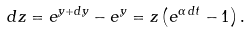Convert formula to latex. <formula><loc_0><loc_0><loc_500><loc_500>d z = e ^ { y + d y } - e ^ { y } = z \left ( e ^ { \alpha \, d t } - 1 \right ) .</formula> 